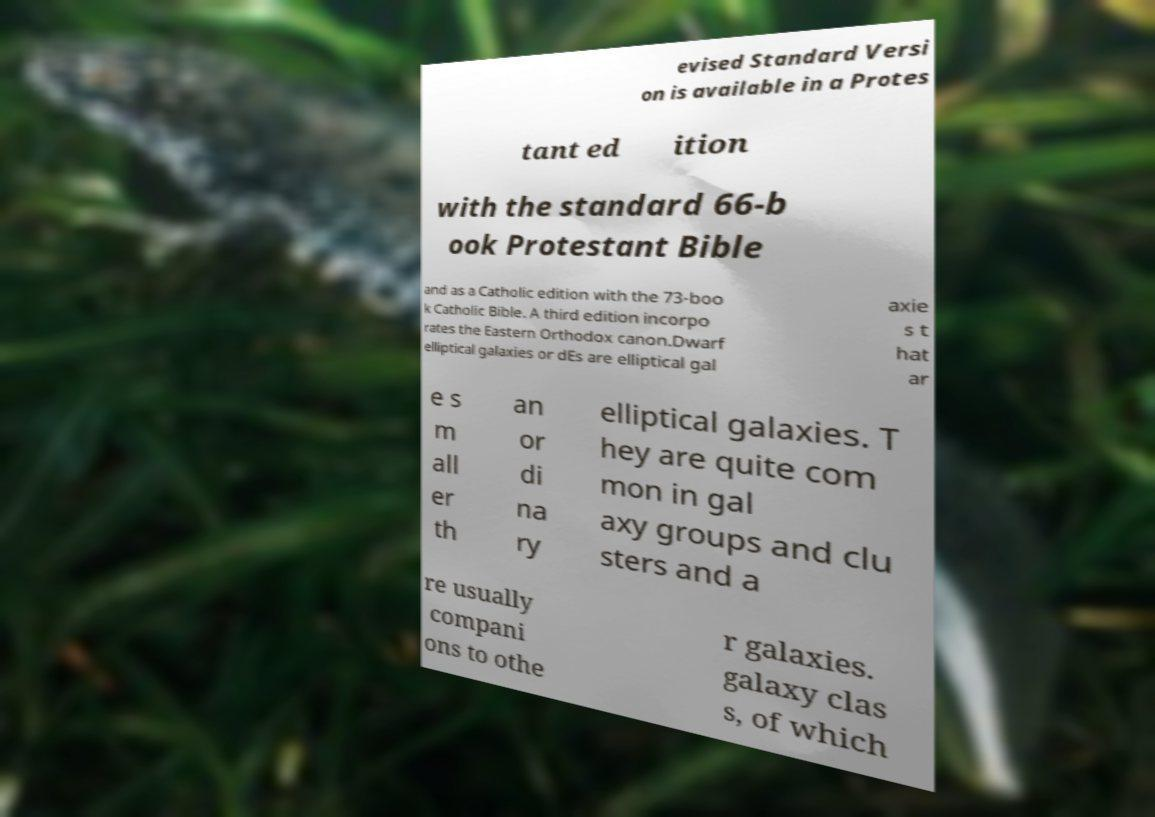I need the written content from this picture converted into text. Can you do that? evised Standard Versi on is available in a Protes tant ed ition with the standard 66-b ook Protestant Bible and as a Catholic edition with the 73-boo k Catholic Bible. A third edition incorpo rates the Eastern Orthodox canon.Dwarf elliptical galaxies or dEs are elliptical gal axie s t hat ar e s m all er th an or di na ry elliptical galaxies. T hey are quite com mon in gal axy groups and clu sters and a re usually compani ons to othe r galaxies. galaxy clas s, of which 